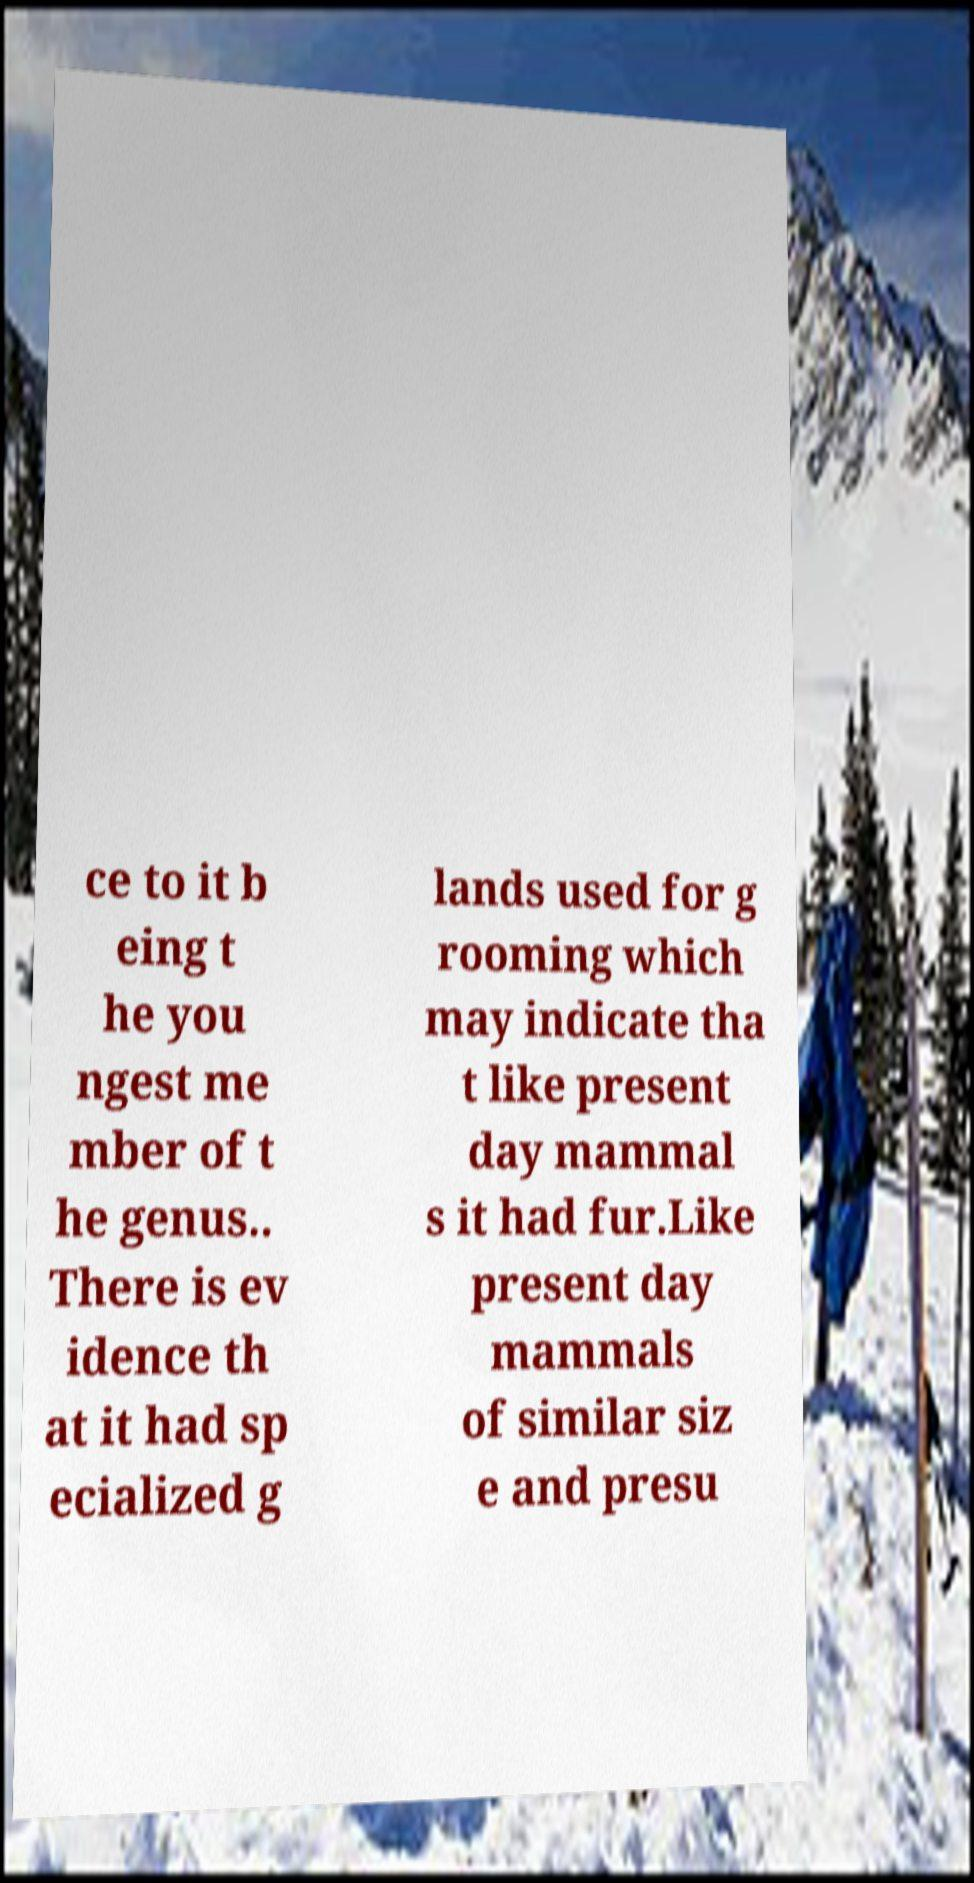Please identify and transcribe the text found in this image. ce to it b eing t he you ngest me mber of t he genus.. There is ev idence th at it had sp ecialized g lands used for g rooming which may indicate tha t like present day mammal s it had fur.Like present day mammals of similar siz e and presu 